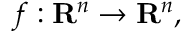Convert formula to latex. <formula><loc_0><loc_0><loc_500><loc_500>f \colon R ^ { n } \rightarrow R ^ { n } ,</formula> 